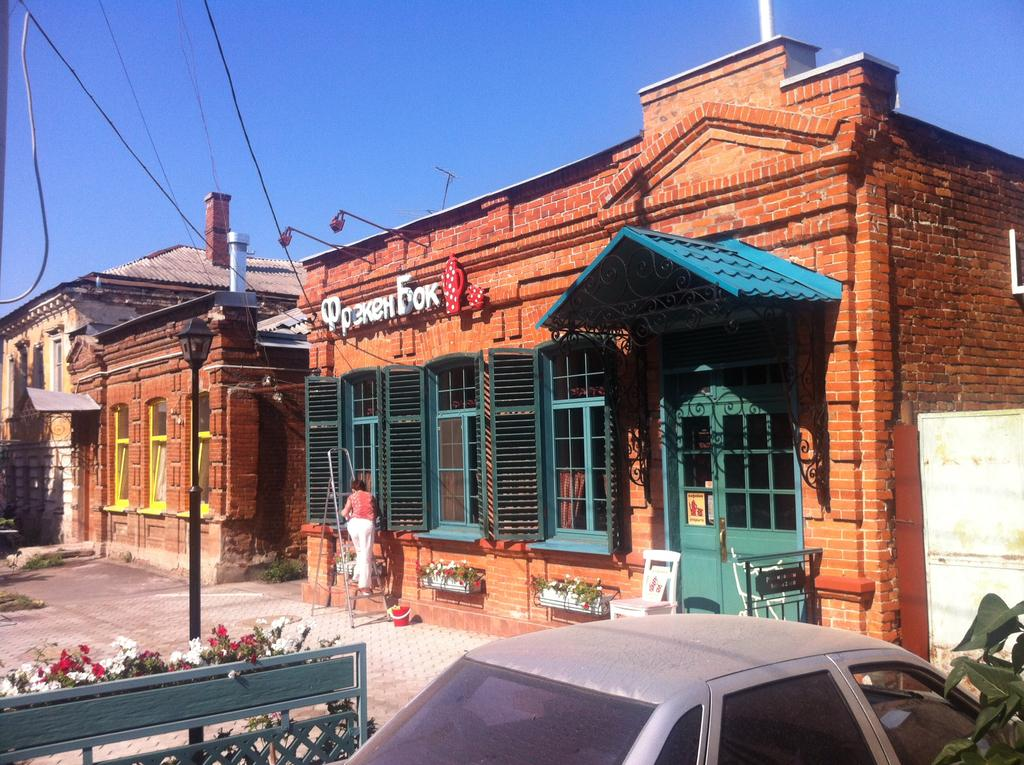What is the main subject of the image? There is a car in the image. Can you describe any features of the car? The car is the main subject, and no specific features are mentioned in the facts. What can be seen in the foreground of the image? Flowers are present in the foreground of the image. What is visible in the background of the image? There are houses, plants, a person, wires, and the sky visible in the background of the image. Can you describe the boundary in the image? Yes, there appears to be a boundary in the image. What color is the person's breath in the image? There is no reference to the person's breath in the image, so it cannot be determined. 